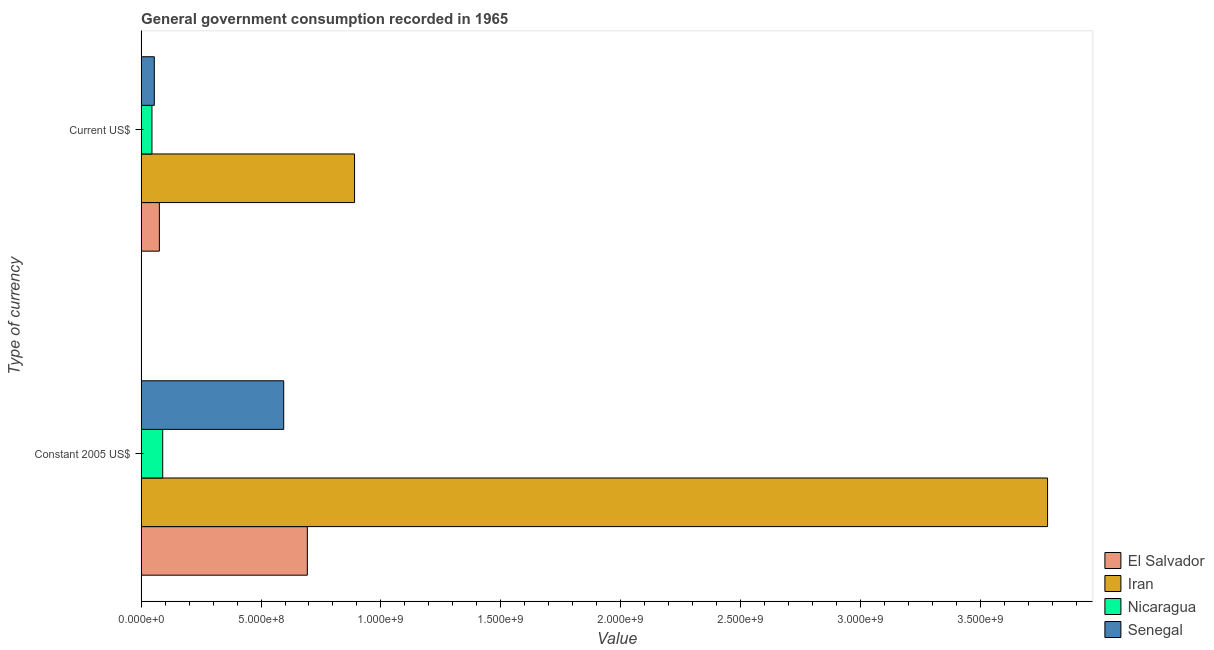How many different coloured bars are there?
Your response must be concise. 4. How many groups of bars are there?
Provide a succinct answer. 2. Are the number of bars per tick equal to the number of legend labels?
Provide a succinct answer. Yes. Are the number of bars on each tick of the Y-axis equal?
Ensure brevity in your answer.  Yes. How many bars are there on the 2nd tick from the top?
Your answer should be very brief. 4. How many bars are there on the 2nd tick from the bottom?
Give a very brief answer. 4. What is the label of the 1st group of bars from the top?
Your response must be concise. Current US$. What is the value consumed in current us$ in Iran?
Make the answer very short. 8.90e+08. Across all countries, what is the maximum value consumed in constant 2005 us$?
Your answer should be very brief. 3.78e+09. Across all countries, what is the minimum value consumed in current us$?
Your response must be concise. 4.50e+07. In which country was the value consumed in current us$ maximum?
Your answer should be compact. Iran. In which country was the value consumed in current us$ minimum?
Your answer should be very brief. Nicaragua. What is the total value consumed in constant 2005 us$ in the graph?
Provide a succinct answer. 5.16e+09. What is the difference between the value consumed in current us$ in Senegal and that in Iran?
Your response must be concise. -8.35e+08. What is the difference between the value consumed in current us$ in El Salvador and the value consumed in constant 2005 us$ in Senegal?
Offer a very short reply. -5.19e+08. What is the average value consumed in constant 2005 us$ per country?
Provide a short and direct response. 1.29e+09. What is the difference between the value consumed in current us$ and value consumed in constant 2005 us$ in Iran?
Offer a terse response. -2.89e+09. In how many countries, is the value consumed in constant 2005 us$ greater than 2300000000 ?
Your response must be concise. 1. What is the ratio of the value consumed in constant 2005 us$ in Iran to that in El Salvador?
Your answer should be very brief. 5.45. Is the value consumed in current us$ in Senegal less than that in Nicaragua?
Provide a short and direct response. No. In how many countries, is the value consumed in current us$ greater than the average value consumed in current us$ taken over all countries?
Provide a short and direct response. 1. What does the 2nd bar from the top in Constant 2005 US$ represents?
Offer a terse response. Nicaragua. What does the 4th bar from the bottom in Constant 2005 US$ represents?
Provide a short and direct response. Senegal. How many countries are there in the graph?
Give a very brief answer. 4. What is the difference between two consecutive major ticks on the X-axis?
Provide a succinct answer. 5.00e+08. Are the values on the major ticks of X-axis written in scientific E-notation?
Keep it short and to the point. Yes. Does the graph contain any zero values?
Give a very brief answer. No. Does the graph contain grids?
Your answer should be very brief. No. Where does the legend appear in the graph?
Offer a very short reply. Bottom right. How are the legend labels stacked?
Ensure brevity in your answer.  Vertical. What is the title of the graph?
Give a very brief answer. General government consumption recorded in 1965. Does "Chile" appear as one of the legend labels in the graph?
Keep it short and to the point. No. What is the label or title of the X-axis?
Your answer should be very brief. Value. What is the label or title of the Y-axis?
Offer a terse response. Type of currency. What is the Value of El Salvador in Constant 2005 US$?
Ensure brevity in your answer.  6.93e+08. What is the Value of Iran in Constant 2005 US$?
Ensure brevity in your answer.  3.78e+09. What is the Value in Nicaragua in Constant 2005 US$?
Give a very brief answer. 9.00e+07. What is the Value of Senegal in Constant 2005 US$?
Ensure brevity in your answer.  5.95e+08. What is the Value of El Salvador in Current US$?
Ensure brevity in your answer.  7.60e+07. What is the Value of Iran in Current US$?
Offer a terse response. 8.90e+08. What is the Value of Nicaragua in Current US$?
Offer a terse response. 4.50e+07. What is the Value of Senegal in Current US$?
Provide a short and direct response. 5.49e+07. Across all Type of currency, what is the maximum Value of El Salvador?
Make the answer very short. 6.93e+08. Across all Type of currency, what is the maximum Value in Iran?
Ensure brevity in your answer.  3.78e+09. Across all Type of currency, what is the maximum Value in Nicaragua?
Your answer should be very brief. 9.00e+07. Across all Type of currency, what is the maximum Value of Senegal?
Give a very brief answer. 5.95e+08. Across all Type of currency, what is the minimum Value in El Salvador?
Your answer should be compact. 7.60e+07. Across all Type of currency, what is the minimum Value of Iran?
Make the answer very short. 8.90e+08. Across all Type of currency, what is the minimum Value in Nicaragua?
Your response must be concise. 4.50e+07. Across all Type of currency, what is the minimum Value in Senegal?
Offer a very short reply. 5.49e+07. What is the total Value of El Salvador in the graph?
Make the answer very short. 7.69e+08. What is the total Value of Iran in the graph?
Offer a very short reply. 4.67e+09. What is the total Value in Nicaragua in the graph?
Offer a terse response. 1.35e+08. What is the total Value of Senegal in the graph?
Provide a short and direct response. 6.49e+08. What is the difference between the Value of El Salvador in Constant 2005 US$ and that in Current US$?
Provide a succinct answer. 6.17e+08. What is the difference between the Value in Iran in Constant 2005 US$ and that in Current US$?
Your answer should be compact. 2.89e+09. What is the difference between the Value of Nicaragua in Constant 2005 US$ and that in Current US$?
Make the answer very short. 4.49e+07. What is the difference between the Value in Senegal in Constant 2005 US$ and that in Current US$?
Make the answer very short. 5.40e+08. What is the difference between the Value in El Salvador in Constant 2005 US$ and the Value in Iran in Current US$?
Your answer should be very brief. -1.97e+08. What is the difference between the Value of El Salvador in Constant 2005 US$ and the Value of Nicaragua in Current US$?
Provide a succinct answer. 6.48e+08. What is the difference between the Value in El Salvador in Constant 2005 US$ and the Value in Senegal in Current US$?
Make the answer very short. 6.38e+08. What is the difference between the Value of Iran in Constant 2005 US$ and the Value of Nicaragua in Current US$?
Your answer should be compact. 3.74e+09. What is the difference between the Value in Iran in Constant 2005 US$ and the Value in Senegal in Current US$?
Provide a succinct answer. 3.73e+09. What is the difference between the Value in Nicaragua in Constant 2005 US$ and the Value in Senegal in Current US$?
Make the answer very short. 3.51e+07. What is the average Value in El Salvador per Type of currency?
Ensure brevity in your answer.  3.85e+08. What is the average Value of Iran per Type of currency?
Keep it short and to the point. 2.34e+09. What is the average Value in Nicaragua per Type of currency?
Ensure brevity in your answer.  6.75e+07. What is the average Value in Senegal per Type of currency?
Offer a terse response. 3.25e+08. What is the difference between the Value of El Salvador and Value of Iran in Constant 2005 US$?
Your answer should be very brief. -3.09e+09. What is the difference between the Value of El Salvador and Value of Nicaragua in Constant 2005 US$?
Your answer should be compact. 6.03e+08. What is the difference between the Value of El Salvador and Value of Senegal in Constant 2005 US$?
Provide a short and direct response. 9.86e+07. What is the difference between the Value in Iran and Value in Nicaragua in Constant 2005 US$?
Your response must be concise. 3.69e+09. What is the difference between the Value of Iran and Value of Senegal in Constant 2005 US$?
Provide a short and direct response. 3.19e+09. What is the difference between the Value of Nicaragua and Value of Senegal in Constant 2005 US$?
Your answer should be compact. -5.05e+08. What is the difference between the Value of El Salvador and Value of Iran in Current US$?
Your response must be concise. -8.14e+08. What is the difference between the Value of El Salvador and Value of Nicaragua in Current US$?
Give a very brief answer. 3.10e+07. What is the difference between the Value of El Salvador and Value of Senegal in Current US$?
Your answer should be very brief. 2.12e+07. What is the difference between the Value in Iran and Value in Nicaragua in Current US$?
Your answer should be compact. 8.45e+08. What is the difference between the Value of Iran and Value of Senegal in Current US$?
Your response must be concise. 8.35e+08. What is the difference between the Value in Nicaragua and Value in Senegal in Current US$?
Keep it short and to the point. -9.83e+06. What is the ratio of the Value in El Salvador in Constant 2005 US$ to that in Current US$?
Provide a short and direct response. 9.12. What is the ratio of the Value of Iran in Constant 2005 US$ to that in Current US$?
Your answer should be very brief. 4.25. What is the ratio of the Value in Nicaragua in Constant 2005 US$ to that in Current US$?
Your response must be concise. 2. What is the ratio of the Value in Senegal in Constant 2005 US$ to that in Current US$?
Provide a short and direct response. 10.83. What is the difference between the highest and the second highest Value of El Salvador?
Keep it short and to the point. 6.17e+08. What is the difference between the highest and the second highest Value of Iran?
Make the answer very short. 2.89e+09. What is the difference between the highest and the second highest Value in Nicaragua?
Give a very brief answer. 4.49e+07. What is the difference between the highest and the second highest Value of Senegal?
Offer a very short reply. 5.40e+08. What is the difference between the highest and the lowest Value in El Salvador?
Give a very brief answer. 6.17e+08. What is the difference between the highest and the lowest Value in Iran?
Provide a short and direct response. 2.89e+09. What is the difference between the highest and the lowest Value of Nicaragua?
Offer a terse response. 4.49e+07. What is the difference between the highest and the lowest Value in Senegal?
Keep it short and to the point. 5.40e+08. 